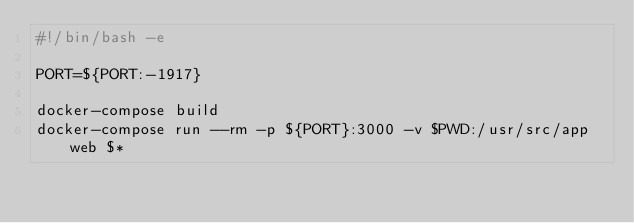Convert code to text. <code><loc_0><loc_0><loc_500><loc_500><_Bash_>#!/bin/bash -e

PORT=${PORT:-1917}

docker-compose build
docker-compose run --rm -p ${PORT}:3000 -v $PWD:/usr/src/app web $*
</code> 